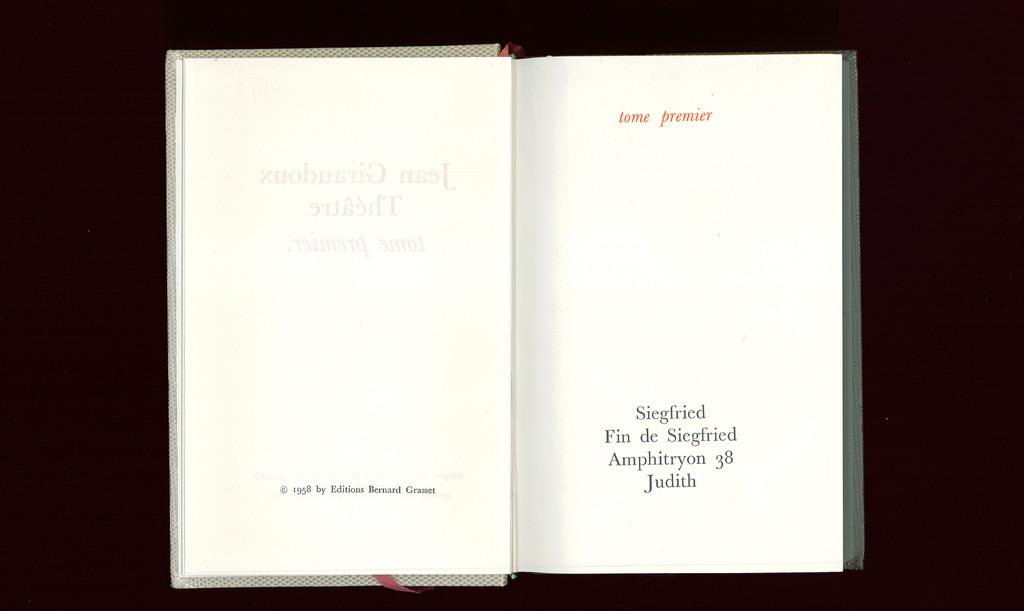<image>
Relay a brief, clear account of the picture shown. A book called Siegfried by Jean Giraudoux is opened and sitting on a black background. 